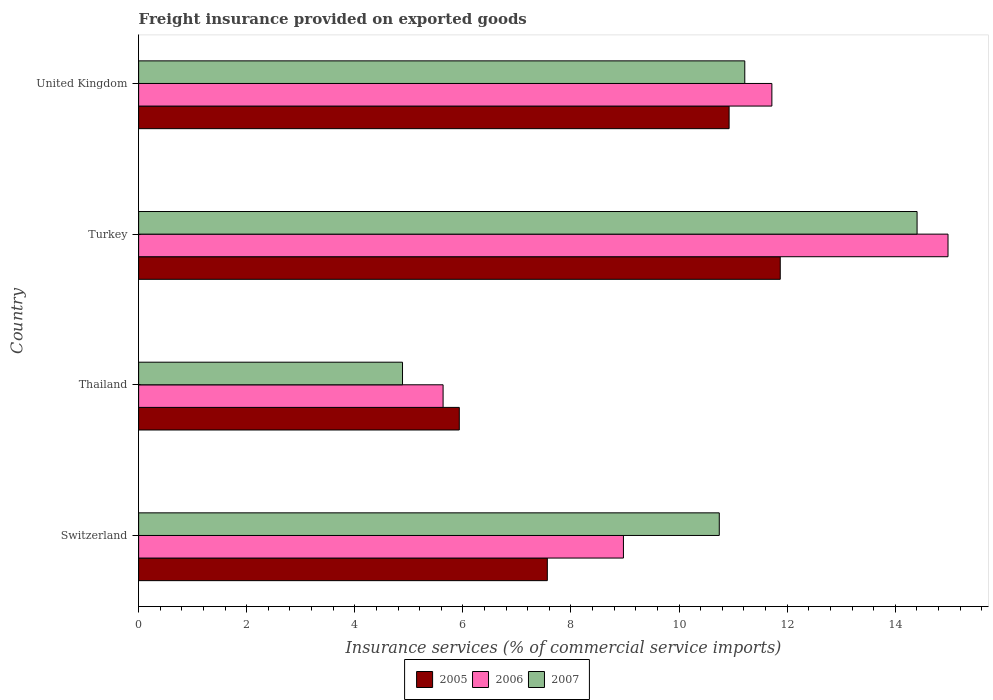Are the number of bars per tick equal to the number of legend labels?
Provide a succinct answer. Yes. How many bars are there on the 1st tick from the bottom?
Ensure brevity in your answer.  3. What is the freight insurance provided on exported goods in 2006 in Switzerland?
Provide a succinct answer. 8.97. Across all countries, what is the maximum freight insurance provided on exported goods in 2005?
Give a very brief answer. 11.87. Across all countries, what is the minimum freight insurance provided on exported goods in 2006?
Offer a terse response. 5.63. In which country was the freight insurance provided on exported goods in 2006 minimum?
Offer a terse response. Thailand. What is the total freight insurance provided on exported goods in 2007 in the graph?
Give a very brief answer. 41.25. What is the difference between the freight insurance provided on exported goods in 2007 in Switzerland and that in Turkey?
Make the answer very short. -3.66. What is the difference between the freight insurance provided on exported goods in 2007 in Thailand and the freight insurance provided on exported goods in 2006 in Switzerland?
Provide a succinct answer. -4.09. What is the average freight insurance provided on exported goods in 2005 per country?
Give a very brief answer. 9.07. What is the difference between the freight insurance provided on exported goods in 2006 and freight insurance provided on exported goods in 2005 in United Kingdom?
Your answer should be compact. 0.79. In how many countries, is the freight insurance provided on exported goods in 2007 greater than 4.8 %?
Give a very brief answer. 4. What is the ratio of the freight insurance provided on exported goods in 2006 in Thailand to that in Turkey?
Ensure brevity in your answer.  0.38. Is the difference between the freight insurance provided on exported goods in 2006 in Thailand and United Kingdom greater than the difference between the freight insurance provided on exported goods in 2005 in Thailand and United Kingdom?
Your answer should be very brief. No. What is the difference between the highest and the second highest freight insurance provided on exported goods in 2006?
Offer a very short reply. 3.26. What is the difference between the highest and the lowest freight insurance provided on exported goods in 2005?
Provide a short and direct response. 5.94. In how many countries, is the freight insurance provided on exported goods in 2007 greater than the average freight insurance provided on exported goods in 2007 taken over all countries?
Provide a short and direct response. 3. Is it the case that in every country, the sum of the freight insurance provided on exported goods in 2006 and freight insurance provided on exported goods in 2005 is greater than the freight insurance provided on exported goods in 2007?
Offer a very short reply. Yes. How many bars are there?
Keep it short and to the point. 12. Are the values on the major ticks of X-axis written in scientific E-notation?
Your answer should be very brief. No. Does the graph contain any zero values?
Your answer should be very brief. No. Where does the legend appear in the graph?
Your response must be concise. Bottom center. What is the title of the graph?
Your answer should be compact. Freight insurance provided on exported goods. What is the label or title of the X-axis?
Offer a very short reply. Insurance services (% of commercial service imports). What is the Insurance services (% of commercial service imports) of 2005 in Switzerland?
Give a very brief answer. 7.56. What is the Insurance services (% of commercial service imports) of 2006 in Switzerland?
Offer a very short reply. 8.97. What is the Insurance services (% of commercial service imports) in 2007 in Switzerland?
Your answer should be compact. 10.74. What is the Insurance services (% of commercial service imports) of 2005 in Thailand?
Offer a very short reply. 5.93. What is the Insurance services (% of commercial service imports) in 2006 in Thailand?
Ensure brevity in your answer.  5.63. What is the Insurance services (% of commercial service imports) in 2007 in Thailand?
Keep it short and to the point. 4.88. What is the Insurance services (% of commercial service imports) in 2005 in Turkey?
Keep it short and to the point. 11.87. What is the Insurance services (% of commercial service imports) in 2006 in Turkey?
Your answer should be compact. 14.98. What is the Insurance services (% of commercial service imports) of 2007 in Turkey?
Your answer should be compact. 14.4. What is the Insurance services (% of commercial service imports) in 2005 in United Kingdom?
Give a very brief answer. 10.93. What is the Insurance services (% of commercial service imports) in 2006 in United Kingdom?
Make the answer very short. 11.72. What is the Insurance services (% of commercial service imports) of 2007 in United Kingdom?
Offer a very short reply. 11.22. Across all countries, what is the maximum Insurance services (% of commercial service imports) of 2005?
Your response must be concise. 11.87. Across all countries, what is the maximum Insurance services (% of commercial service imports) of 2006?
Your answer should be very brief. 14.98. Across all countries, what is the maximum Insurance services (% of commercial service imports) of 2007?
Your response must be concise. 14.4. Across all countries, what is the minimum Insurance services (% of commercial service imports) in 2005?
Keep it short and to the point. 5.93. Across all countries, what is the minimum Insurance services (% of commercial service imports) in 2006?
Offer a terse response. 5.63. Across all countries, what is the minimum Insurance services (% of commercial service imports) in 2007?
Offer a very short reply. 4.88. What is the total Insurance services (% of commercial service imports) of 2005 in the graph?
Your answer should be compact. 36.29. What is the total Insurance services (% of commercial service imports) of 2006 in the graph?
Your answer should be compact. 41.3. What is the total Insurance services (% of commercial service imports) in 2007 in the graph?
Keep it short and to the point. 41.25. What is the difference between the Insurance services (% of commercial service imports) in 2005 in Switzerland and that in Thailand?
Your response must be concise. 1.63. What is the difference between the Insurance services (% of commercial service imports) in 2006 in Switzerland and that in Thailand?
Your response must be concise. 3.34. What is the difference between the Insurance services (% of commercial service imports) in 2007 in Switzerland and that in Thailand?
Offer a terse response. 5.86. What is the difference between the Insurance services (% of commercial service imports) of 2005 in Switzerland and that in Turkey?
Ensure brevity in your answer.  -4.31. What is the difference between the Insurance services (% of commercial service imports) in 2006 in Switzerland and that in Turkey?
Keep it short and to the point. -6.01. What is the difference between the Insurance services (% of commercial service imports) of 2007 in Switzerland and that in Turkey?
Keep it short and to the point. -3.66. What is the difference between the Insurance services (% of commercial service imports) in 2005 in Switzerland and that in United Kingdom?
Your answer should be compact. -3.36. What is the difference between the Insurance services (% of commercial service imports) in 2006 in Switzerland and that in United Kingdom?
Ensure brevity in your answer.  -2.75. What is the difference between the Insurance services (% of commercial service imports) in 2007 in Switzerland and that in United Kingdom?
Provide a short and direct response. -0.47. What is the difference between the Insurance services (% of commercial service imports) of 2005 in Thailand and that in Turkey?
Your response must be concise. -5.94. What is the difference between the Insurance services (% of commercial service imports) in 2006 in Thailand and that in Turkey?
Offer a terse response. -9.34. What is the difference between the Insurance services (% of commercial service imports) in 2007 in Thailand and that in Turkey?
Provide a short and direct response. -9.52. What is the difference between the Insurance services (% of commercial service imports) of 2005 in Thailand and that in United Kingdom?
Ensure brevity in your answer.  -4.99. What is the difference between the Insurance services (% of commercial service imports) in 2006 in Thailand and that in United Kingdom?
Ensure brevity in your answer.  -6.08. What is the difference between the Insurance services (% of commercial service imports) of 2007 in Thailand and that in United Kingdom?
Your response must be concise. -6.33. What is the difference between the Insurance services (% of commercial service imports) in 2005 in Turkey and that in United Kingdom?
Offer a terse response. 0.95. What is the difference between the Insurance services (% of commercial service imports) of 2006 in Turkey and that in United Kingdom?
Provide a short and direct response. 3.26. What is the difference between the Insurance services (% of commercial service imports) in 2007 in Turkey and that in United Kingdom?
Your answer should be very brief. 3.19. What is the difference between the Insurance services (% of commercial service imports) in 2005 in Switzerland and the Insurance services (% of commercial service imports) in 2006 in Thailand?
Give a very brief answer. 1.93. What is the difference between the Insurance services (% of commercial service imports) of 2005 in Switzerland and the Insurance services (% of commercial service imports) of 2007 in Thailand?
Keep it short and to the point. 2.68. What is the difference between the Insurance services (% of commercial service imports) in 2006 in Switzerland and the Insurance services (% of commercial service imports) in 2007 in Thailand?
Your response must be concise. 4.09. What is the difference between the Insurance services (% of commercial service imports) of 2005 in Switzerland and the Insurance services (% of commercial service imports) of 2006 in Turkey?
Offer a very short reply. -7.41. What is the difference between the Insurance services (% of commercial service imports) of 2005 in Switzerland and the Insurance services (% of commercial service imports) of 2007 in Turkey?
Give a very brief answer. -6.84. What is the difference between the Insurance services (% of commercial service imports) of 2006 in Switzerland and the Insurance services (% of commercial service imports) of 2007 in Turkey?
Provide a short and direct response. -5.43. What is the difference between the Insurance services (% of commercial service imports) of 2005 in Switzerland and the Insurance services (% of commercial service imports) of 2006 in United Kingdom?
Provide a short and direct response. -4.16. What is the difference between the Insurance services (% of commercial service imports) of 2005 in Switzerland and the Insurance services (% of commercial service imports) of 2007 in United Kingdom?
Provide a short and direct response. -3.65. What is the difference between the Insurance services (% of commercial service imports) in 2006 in Switzerland and the Insurance services (% of commercial service imports) in 2007 in United Kingdom?
Ensure brevity in your answer.  -2.25. What is the difference between the Insurance services (% of commercial service imports) in 2005 in Thailand and the Insurance services (% of commercial service imports) in 2006 in Turkey?
Provide a short and direct response. -9.04. What is the difference between the Insurance services (% of commercial service imports) of 2005 in Thailand and the Insurance services (% of commercial service imports) of 2007 in Turkey?
Provide a short and direct response. -8.47. What is the difference between the Insurance services (% of commercial service imports) in 2006 in Thailand and the Insurance services (% of commercial service imports) in 2007 in Turkey?
Your response must be concise. -8.77. What is the difference between the Insurance services (% of commercial service imports) of 2005 in Thailand and the Insurance services (% of commercial service imports) of 2006 in United Kingdom?
Your answer should be compact. -5.78. What is the difference between the Insurance services (% of commercial service imports) in 2005 in Thailand and the Insurance services (% of commercial service imports) in 2007 in United Kingdom?
Your answer should be very brief. -5.28. What is the difference between the Insurance services (% of commercial service imports) in 2006 in Thailand and the Insurance services (% of commercial service imports) in 2007 in United Kingdom?
Your response must be concise. -5.58. What is the difference between the Insurance services (% of commercial service imports) of 2005 in Turkey and the Insurance services (% of commercial service imports) of 2006 in United Kingdom?
Your answer should be compact. 0.15. What is the difference between the Insurance services (% of commercial service imports) of 2005 in Turkey and the Insurance services (% of commercial service imports) of 2007 in United Kingdom?
Your answer should be very brief. 0.66. What is the difference between the Insurance services (% of commercial service imports) in 2006 in Turkey and the Insurance services (% of commercial service imports) in 2007 in United Kingdom?
Give a very brief answer. 3.76. What is the average Insurance services (% of commercial service imports) of 2005 per country?
Give a very brief answer. 9.07. What is the average Insurance services (% of commercial service imports) of 2006 per country?
Provide a short and direct response. 10.32. What is the average Insurance services (% of commercial service imports) of 2007 per country?
Ensure brevity in your answer.  10.31. What is the difference between the Insurance services (% of commercial service imports) of 2005 and Insurance services (% of commercial service imports) of 2006 in Switzerland?
Offer a very short reply. -1.41. What is the difference between the Insurance services (% of commercial service imports) of 2005 and Insurance services (% of commercial service imports) of 2007 in Switzerland?
Give a very brief answer. -3.18. What is the difference between the Insurance services (% of commercial service imports) in 2006 and Insurance services (% of commercial service imports) in 2007 in Switzerland?
Ensure brevity in your answer.  -1.77. What is the difference between the Insurance services (% of commercial service imports) of 2005 and Insurance services (% of commercial service imports) of 2006 in Thailand?
Give a very brief answer. 0.3. What is the difference between the Insurance services (% of commercial service imports) in 2005 and Insurance services (% of commercial service imports) in 2007 in Thailand?
Provide a short and direct response. 1.05. What is the difference between the Insurance services (% of commercial service imports) in 2006 and Insurance services (% of commercial service imports) in 2007 in Thailand?
Ensure brevity in your answer.  0.75. What is the difference between the Insurance services (% of commercial service imports) of 2005 and Insurance services (% of commercial service imports) of 2006 in Turkey?
Keep it short and to the point. -3.1. What is the difference between the Insurance services (% of commercial service imports) in 2005 and Insurance services (% of commercial service imports) in 2007 in Turkey?
Your answer should be compact. -2.53. What is the difference between the Insurance services (% of commercial service imports) of 2006 and Insurance services (% of commercial service imports) of 2007 in Turkey?
Your answer should be very brief. 0.57. What is the difference between the Insurance services (% of commercial service imports) in 2005 and Insurance services (% of commercial service imports) in 2006 in United Kingdom?
Make the answer very short. -0.79. What is the difference between the Insurance services (% of commercial service imports) of 2005 and Insurance services (% of commercial service imports) of 2007 in United Kingdom?
Keep it short and to the point. -0.29. What is the difference between the Insurance services (% of commercial service imports) of 2006 and Insurance services (% of commercial service imports) of 2007 in United Kingdom?
Keep it short and to the point. 0.5. What is the ratio of the Insurance services (% of commercial service imports) in 2005 in Switzerland to that in Thailand?
Give a very brief answer. 1.27. What is the ratio of the Insurance services (% of commercial service imports) in 2006 in Switzerland to that in Thailand?
Your answer should be very brief. 1.59. What is the ratio of the Insurance services (% of commercial service imports) of 2007 in Switzerland to that in Thailand?
Offer a terse response. 2.2. What is the ratio of the Insurance services (% of commercial service imports) of 2005 in Switzerland to that in Turkey?
Offer a very short reply. 0.64. What is the ratio of the Insurance services (% of commercial service imports) of 2006 in Switzerland to that in Turkey?
Your answer should be compact. 0.6. What is the ratio of the Insurance services (% of commercial service imports) in 2007 in Switzerland to that in Turkey?
Offer a terse response. 0.75. What is the ratio of the Insurance services (% of commercial service imports) of 2005 in Switzerland to that in United Kingdom?
Keep it short and to the point. 0.69. What is the ratio of the Insurance services (% of commercial service imports) in 2006 in Switzerland to that in United Kingdom?
Offer a very short reply. 0.77. What is the ratio of the Insurance services (% of commercial service imports) of 2007 in Switzerland to that in United Kingdom?
Provide a short and direct response. 0.96. What is the ratio of the Insurance services (% of commercial service imports) of 2005 in Thailand to that in Turkey?
Offer a very short reply. 0.5. What is the ratio of the Insurance services (% of commercial service imports) in 2006 in Thailand to that in Turkey?
Ensure brevity in your answer.  0.38. What is the ratio of the Insurance services (% of commercial service imports) in 2007 in Thailand to that in Turkey?
Your answer should be compact. 0.34. What is the ratio of the Insurance services (% of commercial service imports) in 2005 in Thailand to that in United Kingdom?
Provide a short and direct response. 0.54. What is the ratio of the Insurance services (% of commercial service imports) in 2006 in Thailand to that in United Kingdom?
Offer a very short reply. 0.48. What is the ratio of the Insurance services (% of commercial service imports) of 2007 in Thailand to that in United Kingdom?
Your answer should be compact. 0.44. What is the ratio of the Insurance services (% of commercial service imports) in 2005 in Turkey to that in United Kingdom?
Ensure brevity in your answer.  1.09. What is the ratio of the Insurance services (% of commercial service imports) in 2006 in Turkey to that in United Kingdom?
Keep it short and to the point. 1.28. What is the ratio of the Insurance services (% of commercial service imports) in 2007 in Turkey to that in United Kingdom?
Provide a succinct answer. 1.28. What is the difference between the highest and the second highest Insurance services (% of commercial service imports) of 2005?
Provide a succinct answer. 0.95. What is the difference between the highest and the second highest Insurance services (% of commercial service imports) of 2006?
Your answer should be very brief. 3.26. What is the difference between the highest and the second highest Insurance services (% of commercial service imports) in 2007?
Your answer should be compact. 3.19. What is the difference between the highest and the lowest Insurance services (% of commercial service imports) of 2005?
Your response must be concise. 5.94. What is the difference between the highest and the lowest Insurance services (% of commercial service imports) of 2006?
Keep it short and to the point. 9.34. What is the difference between the highest and the lowest Insurance services (% of commercial service imports) of 2007?
Offer a very short reply. 9.52. 